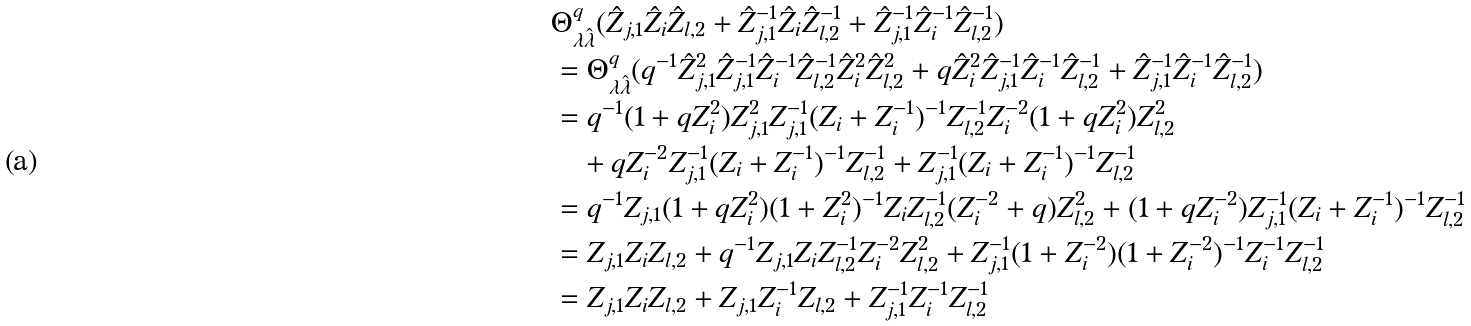<formula> <loc_0><loc_0><loc_500><loc_500>& \Theta ^ { q } _ { \lambda \hat { \lambda } } ( \hat { Z } _ { j , 1 } \hat { Z } _ { i } \hat { Z } _ { l , 2 } + \hat { Z } _ { j , 1 } ^ { - 1 } \hat { Z } _ { i } \hat { Z } _ { l , 2 } ^ { - 1 } + \hat { Z } _ { j , 1 } ^ { - 1 } \hat { Z } _ { i } ^ { - 1 } \hat { Z } _ { l , 2 } ^ { - 1 } ) \\ & = \Theta ^ { q } _ { \lambda \hat { \lambda } } ( q ^ { - 1 } \hat { Z } _ { j , 1 } ^ { 2 } \hat { Z } _ { j , 1 } ^ { - 1 } \hat { Z } _ { i } ^ { - 1 } \hat { Z } _ { l , 2 } ^ { - 1 } \hat { Z } _ { i } ^ { 2 } \hat { Z } _ { l , 2 } ^ { 2 } + q \hat { Z } _ { i } ^ { 2 } \hat { Z } _ { j , 1 } ^ { - 1 } \hat { Z } _ { i } ^ { - 1 } \hat { Z } _ { l , 2 } ^ { - 1 } + \hat { Z } _ { j , 1 } ^ { - 1 } \hat { Z } _ { i } ^ { - 1 } \hat { Z } _ { l , 2 } ^ { - 1 } ) \\ & = q ^ { - 1 } ( 1 + q Z _ { i } ^ { 2 } ) Z _ { j , 1 } ^ { 2 } Z _ { j , 1 } ^ { - 1 } ( Z _ { i } + Z _ { i } ^ { - 1 } ) ^ { - 1 } Z _ { l , 2 } ^ { - 1 } Z _ { i } ^ { - 2 } ( 1 + q Z _ { i } ^ { 2 } ) Z _ { l , 2 } ^ { 2 } \\ & \quad + q Z _ { i } ^ { - 2 } Z _ { j , 1 } ^ { - 1 } ( Z _ { i } + Z _ { i } ^ { - 1 } ) ^ { - 1 } Z _ { l , 2 } ^ { - 1 } + Z _ { j , 1 } ^ { - 1 } ( Z _ { i } + Z _ { i } ^ { - 1 } ) ^ { - 1 } Z _ { l , 2 } ^ { - 1 } \\ & = q ^ { - 1 } Z _ { j , 1 } ( 1 + q Z _ { i } ^ { 2 } ) ( 1 + Z _ { i } ^ { 2 } ) ^ { - 1 } Z _ { i } Z _ { l , 2 } ^ { - 1 } ( Z _ { i } ^ { - 2 } + q ) Z _ { l , 2 } ^ { 2 } + ( 1 + q Z _ { i } ^ { - 2 } ) Z _ { j , 1 } ^ { - 1 } ( Z _ { i } + Z _ { i } ^ { - 1 } ) ^ { - 1 } Z _ { l , 2 } ^ { - 1 } \\ & = Z _ { j , 1 } Z _ { i } Z _ { l , 2 } + q ^ { - 1 } Z _ { j , 1 } Z _ { i } Z _ { l , 2 } ^ { - 1 } Z _ { i } ^ { - 2 } Z _ { l , 2 } ^ { 2 } + Z _ { j , 1 } ^ { - 1 } ( 1 + Z _ { i } ^ { - 2 } ) ( 1 + Z _ { i } ^ { - 2 } ) ^ { - 1 } Z _ { i } ^ { - 1 } Z _ { l , 2 } ^ { - 1 } \\ & = Z _ { j , 1 } Z _ { i } Z _ { l , 2 } + Z _ { j , 1 } Z _ { i } ^ { - 1 } Z _ { l , 2 } + Z _ { j , 1 } ^ { - 1 } Z _ { i } ^ { - 1 } Z _ { l , 2 } ^ { - 1 }</formula> 